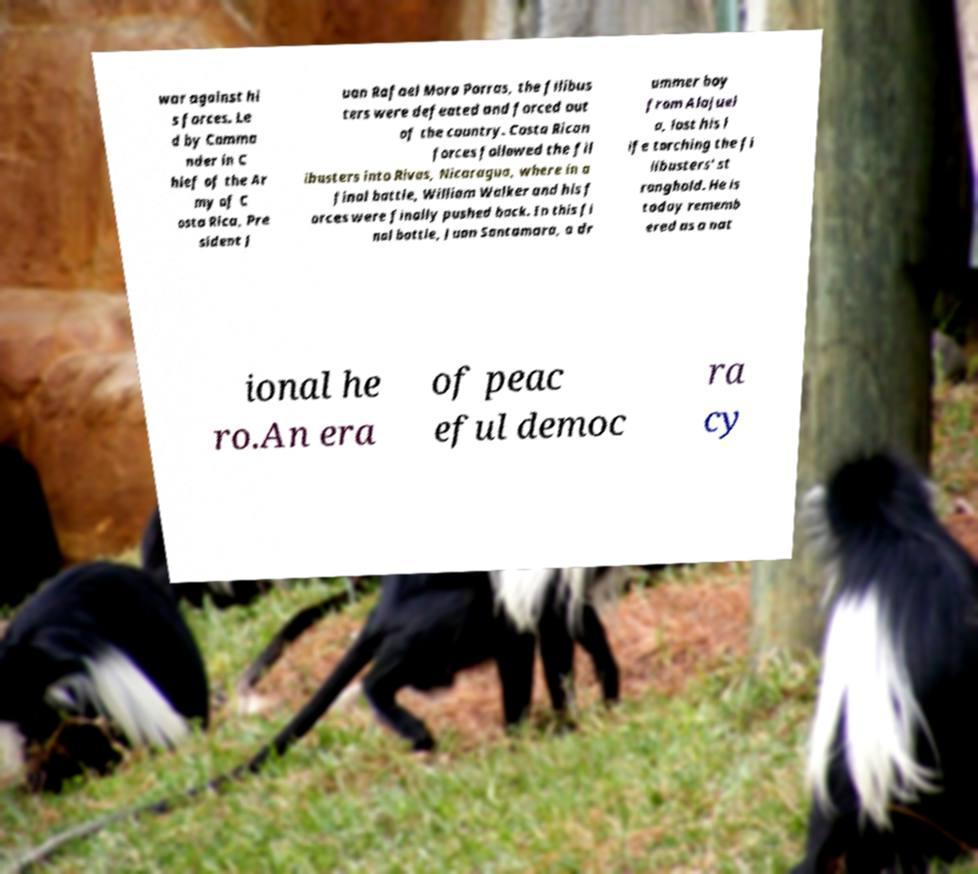For documentation purposes, I need the text within this image transcribed. Could you provide that? war against hi s forces. Le d by Comma nder in C hief of the Ar my of C osta Rica, Pre sident J uan Rafael Mora Porras, the filibus ters were defeated and forced out of the country. Costa Rican forces followed the fil ibusters into Rivas, Nicaragua, where in a final battle, William Walker and his f orces were finally pushed back. In this fi nal battle, Juan Santamara, a dr ummer boy from Alajuel a, lost his l ife torching the fi libusters' st ronghold. He is today rememb ered as a nat ional he ro.An era of peac eful democ ra cy 